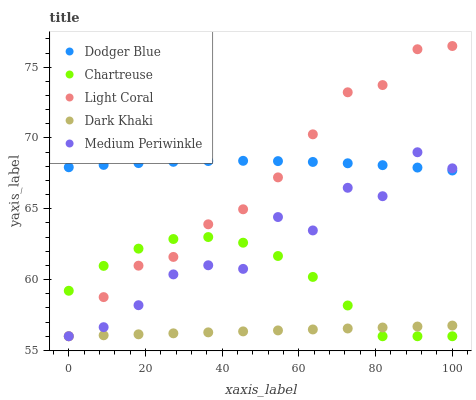Does Dark Khaki have the minimum area under the curve?
Answer yes or no. Yes. Does Dodger Blue have the maximum area under the curve?
Answer yes or no. Yes. Does Chartreuse have the minimum area under the curve?
Answer yes or no. No. Does Chartreuse have the maximum area under the curve?
Answer yes or no. No. Is Dark Khaki the smoothest?
Answer yes or no. Yes. Is Medium Periwinkle the roughest?
Answer yes or no. Yes. Is Chartreuse the smoothest?
Answer yes or no. No. Is Chartreuse the roughest?
Answer yes or no. No. Does Light Coral have the lowest value?
Answer yes or no. Yes. Does Dodger Blue have the lowest value?
Answer yes or no. No. Does Light Coral have the highest value?
Answer yes or no. Yes. Does Chartreuse have the highest value?
Answer yes or no. No. Is Chartreuse less than Dodger Blue?
Answer yes or no. Yes. Is Dodger Blue greater than Dark Khaki?
Answer yes or no. Yes. Does Medium Periwinkle intersect Chartreuse?
Answer yes or no. Yes. Is Medium Periwinkle less than Chartreuse?
Answer yes or no. No. Is Medium Periwinkle greater than Chartreuse?
Answer yes or no. No. Does Chartreuse intersect Dodger Blue?
Answer yes or no. No. 